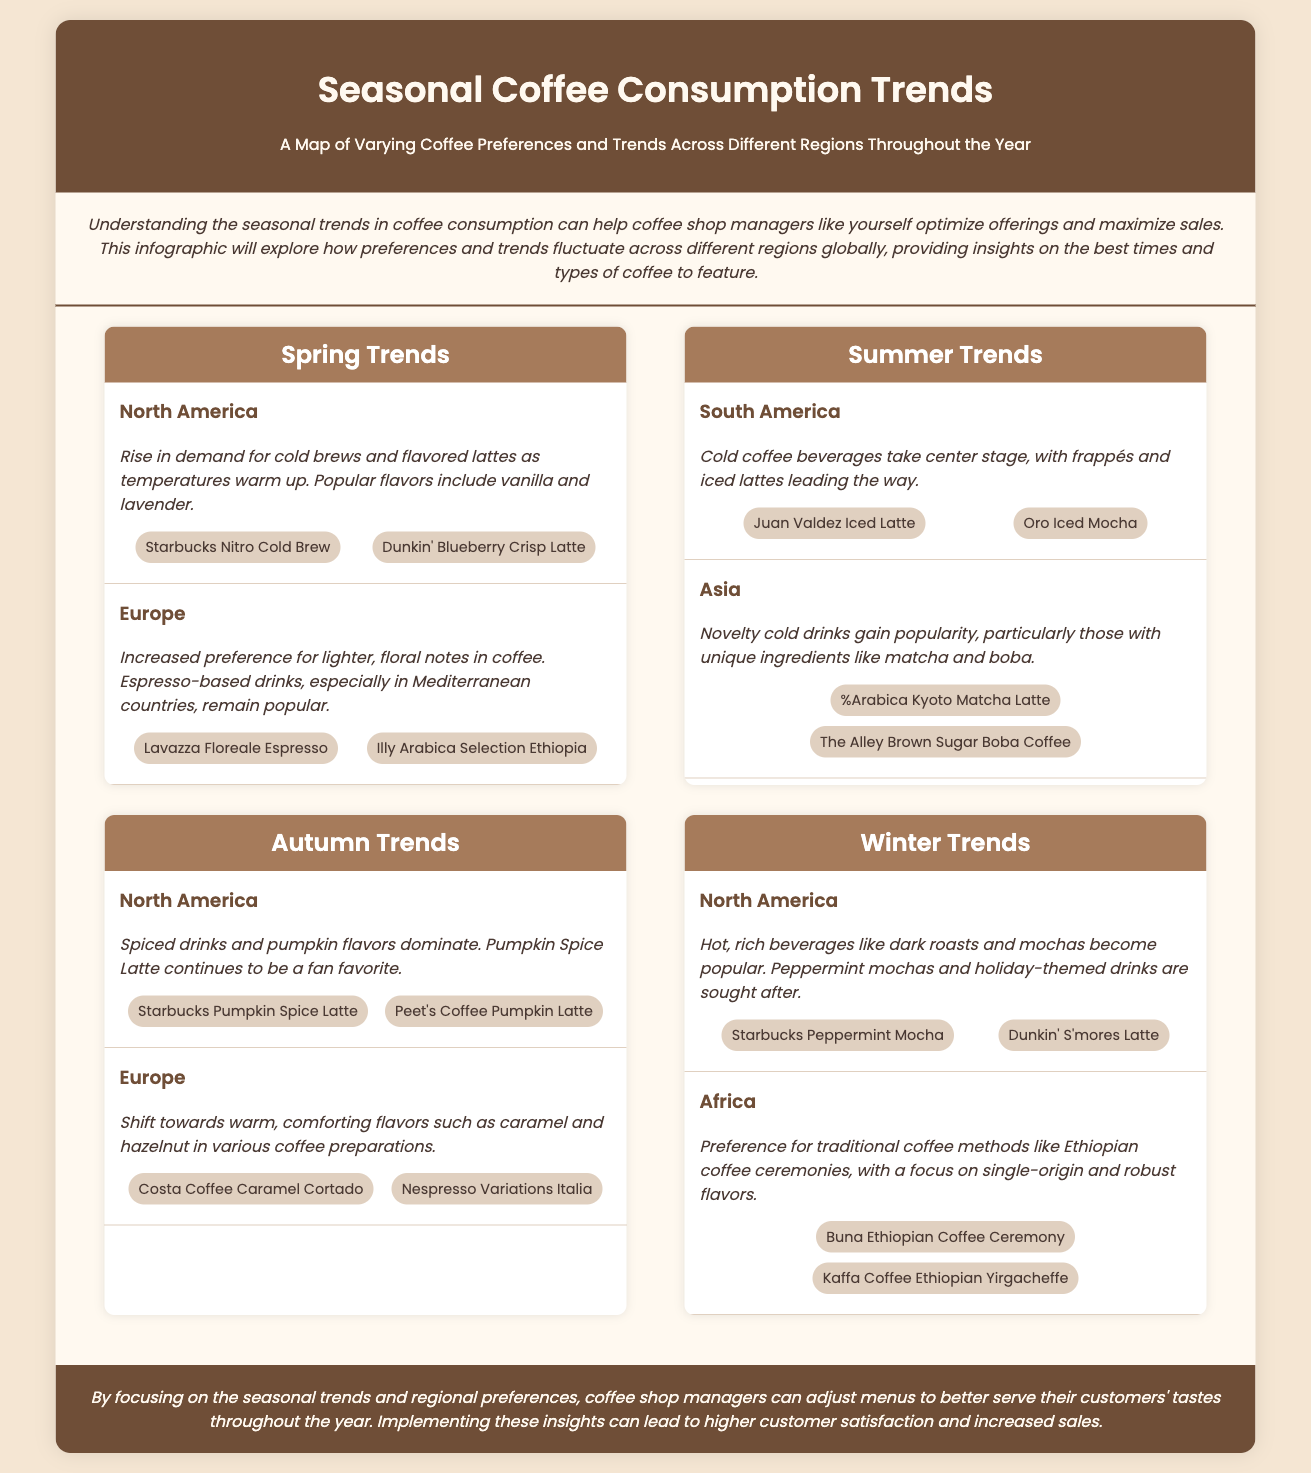what are popular flavors in North America during spring? The document states that in North America during spring, popular flavors include vanilla and lavender.
Answer: vanilla and lavender which cold drink is popular in South America during summer? According to the document, frappés and iced lattes are leading the way in South America during summer.
Answer: frappés and iced lattes what seasonal trend is highlighted for North America in autumn? The trend for North America in autumn highlights spiced drinks and pumpkin flavors, particularly the Pumpkin Spice Latte.
Answer: Pumpkin Spice Latte what unique drink is popular in Asia during summer? The document mentions that novelty cold drinks with unique ingredients like matcha and boba gain popularity in Asia during summer.
Answer: matcha and boba which coffee preparation is emphasized in Africa during winter? The document emphasizes the preference for traditional coffee methods like Ethiopian coffee ceremonies in Africa during winter.
Answer: Ethiopian coffee ceremonies what is a key trend for Europe in spring? The key trend for Europe in spring is the increased preference for lighter, floral notes in coffee.
Answer: lighter, floral notes which drink is mentioned for the autumn season in Europe? The document lists Costa Coffee Caramel Cortado and Nespresso Variations Italia as drinks for the autumn season in Europe.
Answer: Costa Coffee Caramel Cortado, Nespresso Variations Italia how do preferences change in Europe from autumn to winter? The document indicates that in autumn, comforting flavors such as caramel and hazelnut become popular, while winter favorites include hot, rich beverages.
Answer: comforting flavors, hot, rich beverages 